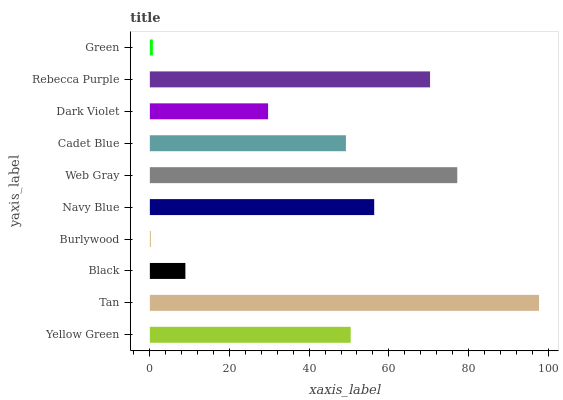Is Burlywood the minimum?
Answer yes or no. Yes. Is Tan the maximum?
Answer yes or no. Yes. Is Black the minimum?
Answer yes or no. No. Is Black the maximum?
Answer yes or no. No. Is Tan greater than Black?
Answer yes or no. Yes. Is Black less than Tan?
Answer yes or no. Yes. Is Black greater than Tan?
Answer yes or no. No. Is Tan less than Black?
Answer yes or no. No. Is Yellow Green the high median?
Answer yes or no. Yes. Is Cadet Blue the low median?
Answer yes or no. Yes. Is Navy Blue the high median?
Answer yes or no. No. Is Rebecca Purple the low median?
Answer yes or no. No. 